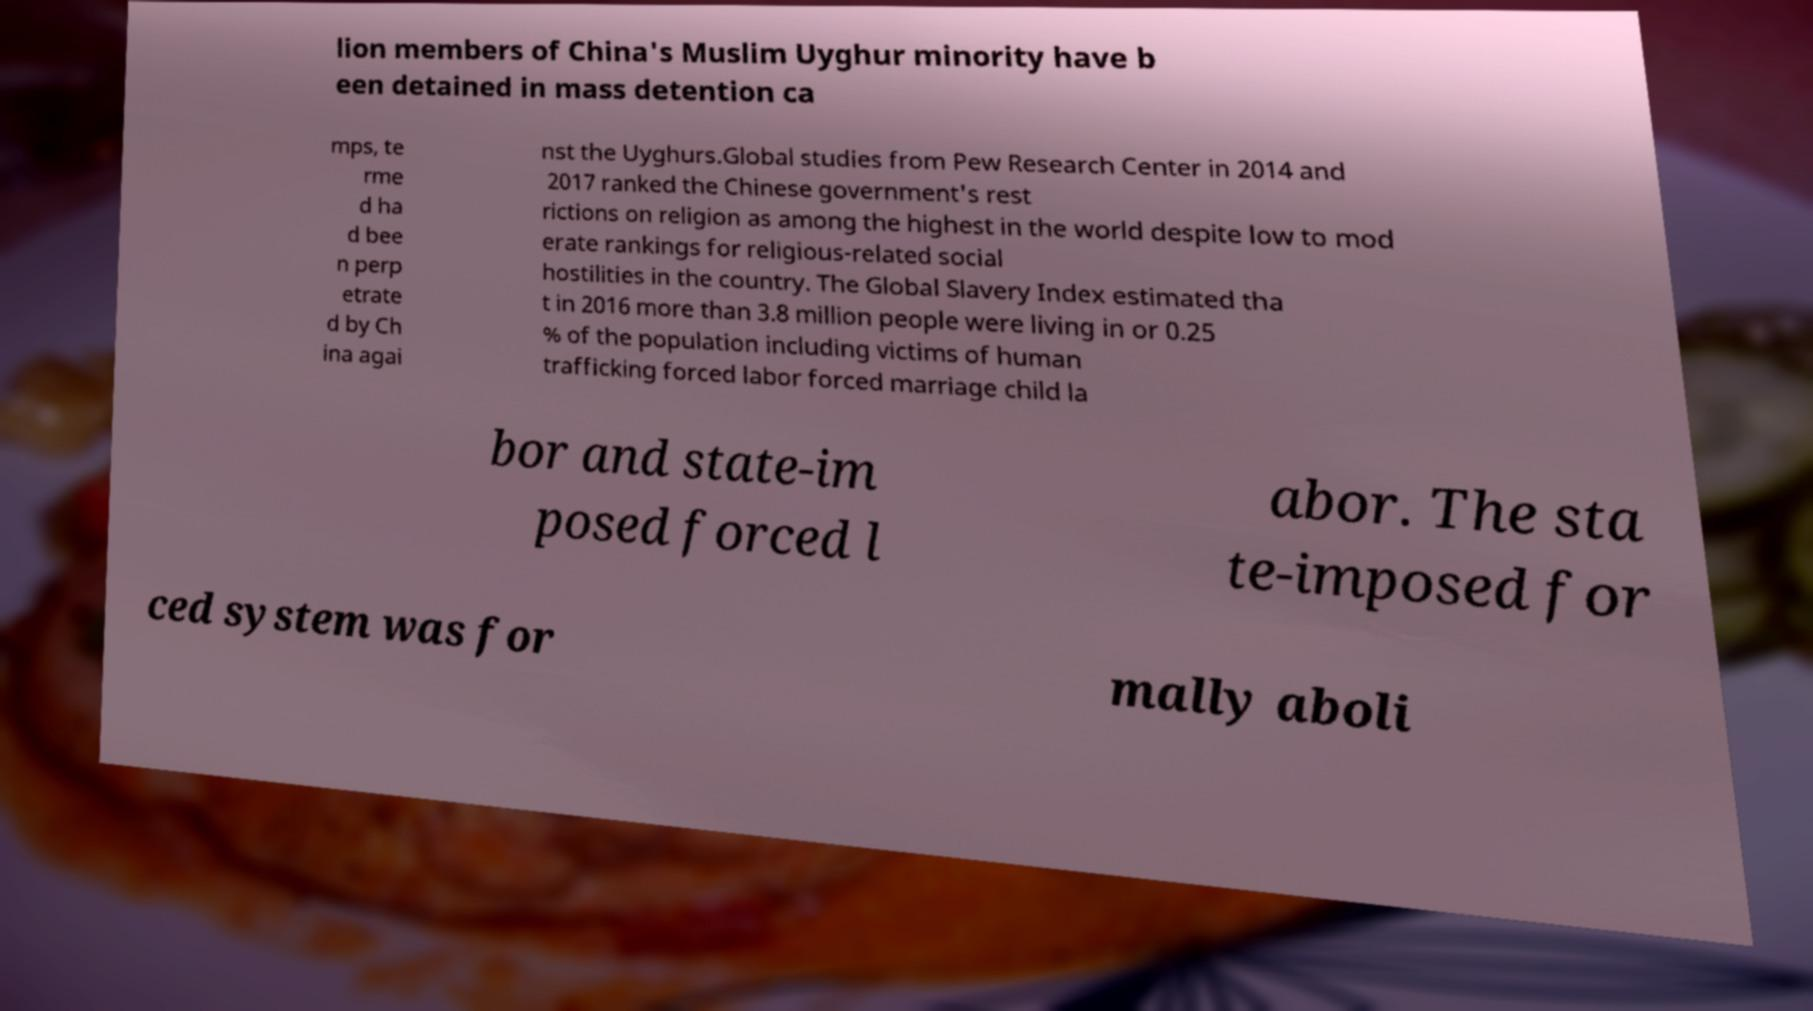Can you read and provide the text displayed in the image?This photo seems to have some interesting text. Can you extract and type it out for me? lion members of China's Muslim Uyghur minority have b een detained in mass detention ca mps, te rme d ha d bee n perp etrate d by Ch ina agai nst the Uyghurs.Global studies from Pew Research Center in 2014 and 2017 ranked the Chinese government's rest rictions on religion as among the highest in the world despite low to mod erate rankings for religious-related social hostilities in the country. The Global Slavery Index estimated tha t in 2016 more than 3.8 million people were living in or 0.25 % of the population including victims of human trafficking forced labor forced marriage child la bor and state-im posed forced l abor. The sta te-imposed for ced system was for mally aboli 